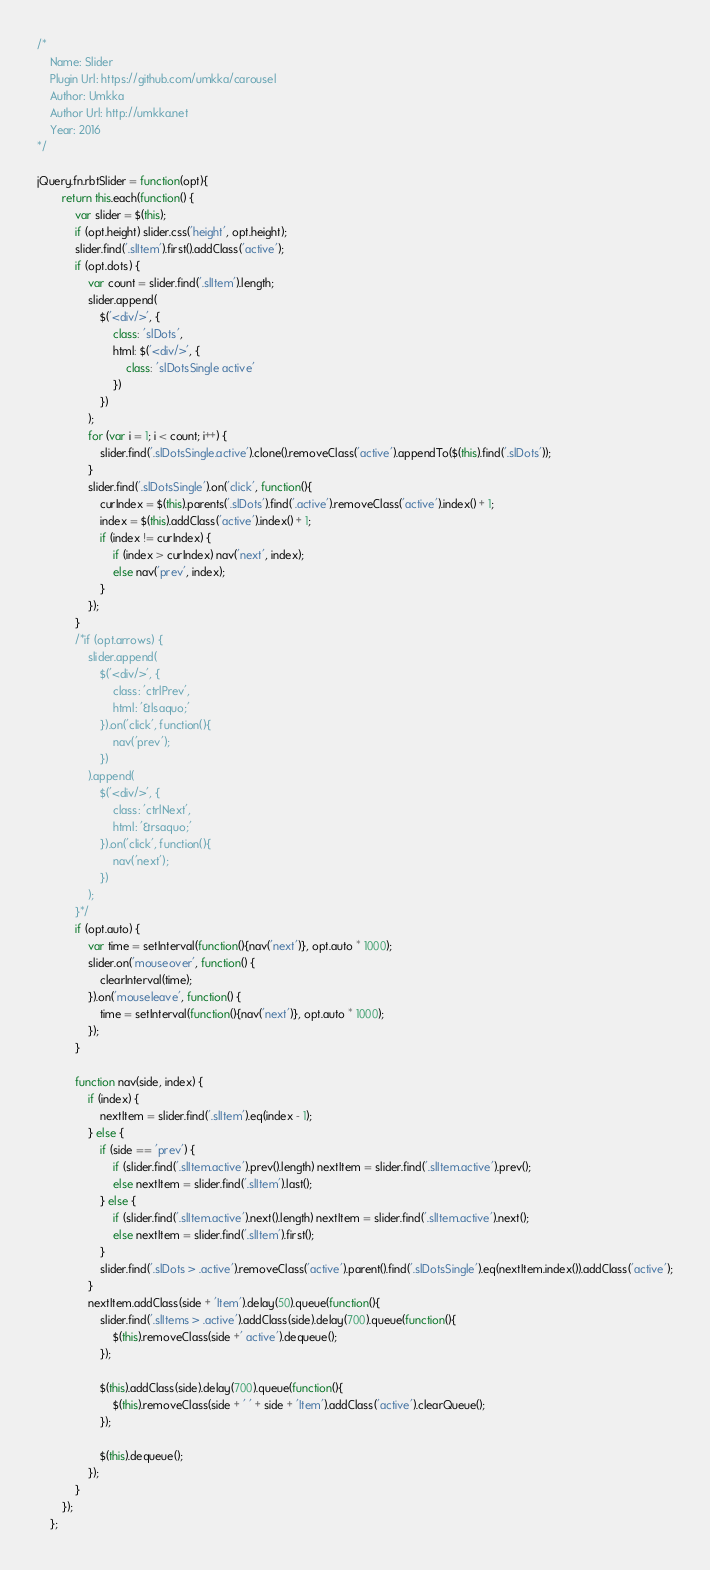Convert code to text. <code><loc_0><loc_0><loc_500><loc_500><_JavaScript_>/*
    Name: Slider
    Plugin Url: https://github.com/umkka/carousel
    Author: Umkka
    Author Url: http://umkka.net
    Year: 2016
*/

jQuery.fn.rbtSlider = function(opt){
        return this.each(function() {
            var slider = $(this);
            if (opt.height) slider.css('height', opt.height);
            slider.find('.slItem').first().addClass('active');
            if (opt.dots) {
                var count = slider.find('.slItem').length;
                slider.append(
                    $('<div/>', {
                        class: 'slDots',
                        html: $('<div/>', {
                            class: 'slDotsSingle active'
                        })
                    })
                );
                for (var i = 1; i < count; i++) {
                    slider.find('.slDotsSingle.active').clone().removeClass('active').appendTo($(this).find('.slDots'));
                }
                slider.find('.slDotsSingle').on('click', function(){
                    curIndex = $(this).parents('.slDots').find('.active').removeClass('active').index() + 1;
                    index = $(this).addClass('active').index() + 1;
                    if (index != curIndex) {
                        if (index > curIndex) nav('next', index);
                        else nav('prev', index);
                    }
                });
            }
            /*if (opt.arrows) {
                slider.append(
                    $('<div/>', {
                        class: 'ctrlPrev',
                        html: '&lsaquo;'
                    }).on('click', function(){
                        nav('prev');
                    })
                ).append(
                    $('<div/>', {
                        class: 'ctrlNext',
                        html: '&rsaquo;'
                    }).on('click', function(){
                        nav('next');
                    })
                );
            }*/
            if (opt.auto) {
                var time = setInterval(function(){nav('next')}, opt.auto * 1000);
                slider.on('mouseover', function() {
                    clearInterval(time);
                }).on('mouseleave', function() {
                    time = setInterval(function(){nav('next')}, opt.auto * 1000);
                });
            }

            function nav(side, index) {
                if (index) {
                    nextItem = slider.find('.slItem').eq(index - 1);
                } else {
                    if (side == 'prev') {
                        if (slider.find('.slItem.active').prev().length) nextItem = slider.find('.slItem.active').prev();
                        else nextItem = slider.find('.slItem').last();
                    } else {
                        if (slider.find('.slItem.active').next().length) nextItem = slider.find('.slItem.active').next();
                        else nextItem = slider.find('.slItem').first();
                    }
                    slider.find('.slDots > .active').removeClass('active').parent().find('.slDotsSingle').eq(nextItem.index()).addClass('active');
                }
                nextItem.addClass(side + 'Item').delay(50).queue(function(){
                    slider.find('.slItems > .active').addClass(side).delay(700).queue(function(){
                        $(this).removeClass(side +' active').dequeue();
                    });

                    $(this).addClass(side).delay(700).queue(function(){
                        $(this).removeClass(side + ' ' + side + 'Item').addClass('active').clearQueue();
                    });

                    $(this).dequeue();
                });
            }
        });
    };
</code> 